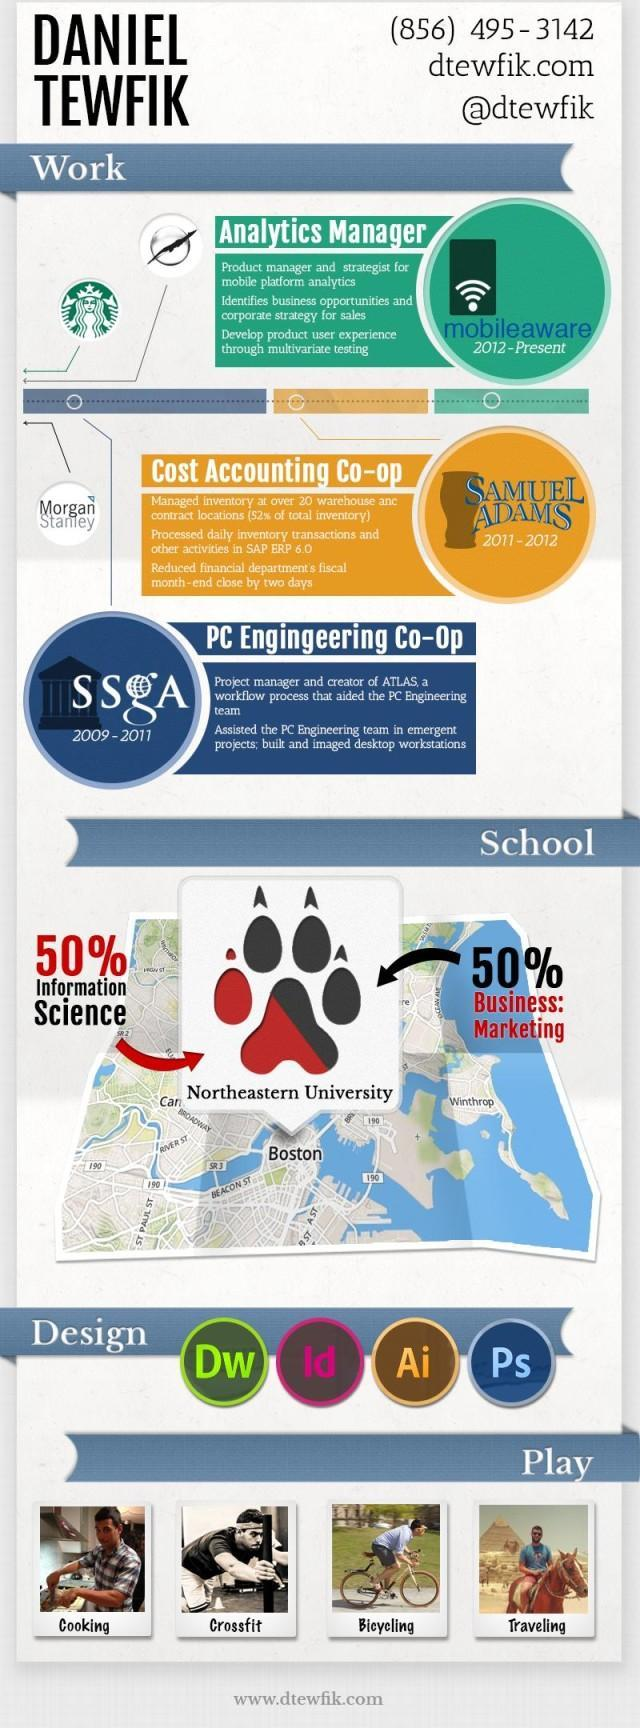Where did Daniel Tewfik manage inventory?
Answer the question with a short phrase. SAMUEL ADAMS Where is the Northeastern university located as per the map? Boston 